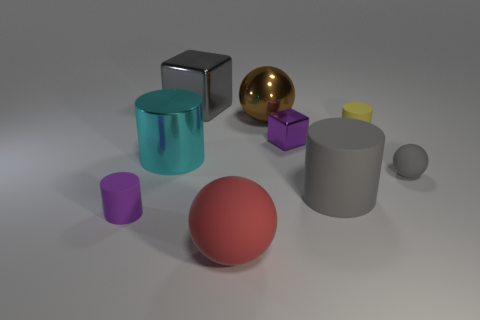Subtract all gray cylinders. How many cylinders are left? 3 Subtract all purple cylinders. How many cylinders are left? 3 Subtract 2 cylinders. How many cylinders are left? 2 Add 1 big gray matte cylinders. How many objects exist? 10 Subtract all blocks. How many objects are left? 7 Subtract all green cylinders. Subtract all purple cubes. How many cylinders are left? 4 Add 5 large metal things. How many large metal things exist? 8 Subtract 1 brown balls. How many objects are left? 8 Subtract all large shiny spheres. Subtract all red rubber balls. How many objects are left? 7 Add 5 gray rubber balls. How many gray rubber balls are left? 6 